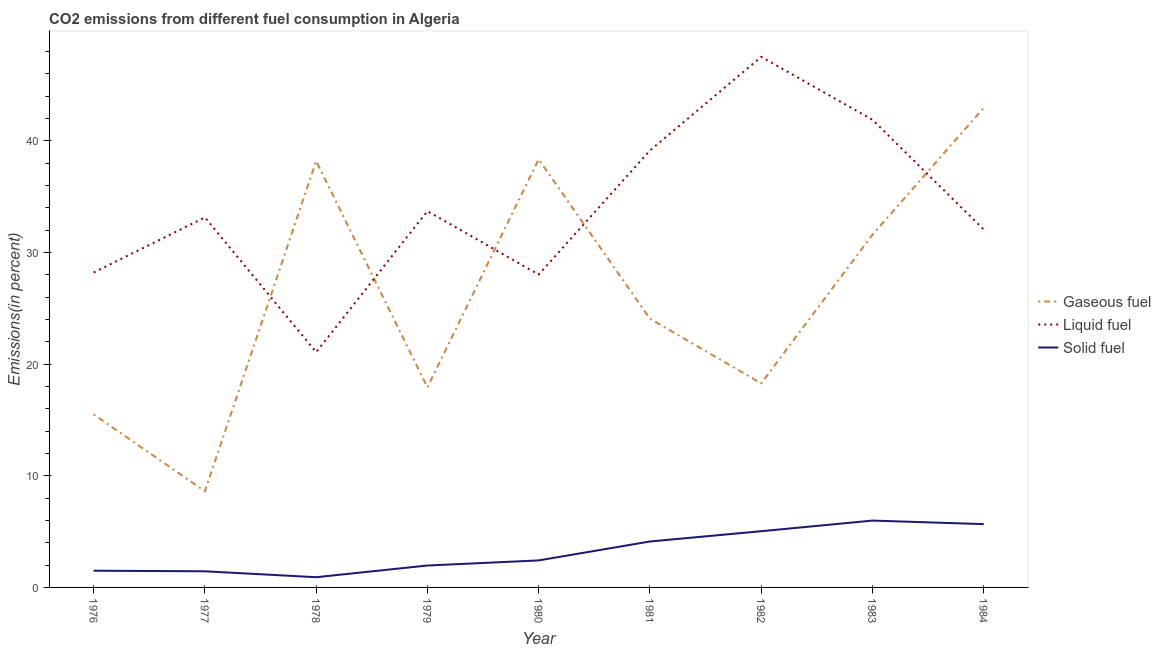How many different coloured lines are there?
Ensure brevity in your answer.  3. What is the percentage of liquid fuel emission in 1978?
Provide a succinct answer. 21.07. Across all years, what is the maximum percentage of solid fuel emission?
Offer a terse response. 5.99. Across all years, what is the minimum percentage of solid fuel emission?
Provide a succinct answer. 0.91. In which year was the percentage of gaseous fuel emission maximum?
Ensure brevity in your answer.  1984. What is the total percentage of solid fuel emission in the graph?
Offer a very short reply. 29.04. What is the difference between the percentage of liquid fuel emission in 1976 and that in 1981?
Offer a terse response. -10.93. What is the difference between the percentage of solid fuel emission in 1979 and the percentage of gaseous fuel emission in 1977?
Offer a very short reply. -6.65. What is the average percentage of solid fuel emission per year?
Your response must be concise. 3.23. In the year 1981, what is the difference between the percentage of gaseous fuel emission and percentage of liquid fuel emission?
Offer a terse response. -15.07. What is the ratio of the percentage of solid fuel emission in 1980 to that in 1983?
Provide a short and direct response. 0.4. What is the difference between the highest and the second highest percentage of liquid fuel emission?
Your response must be concise. 5.63. What is the difference between the highest and the lowest percentage of solid fuel emission?
Provide a succinct answer. 5.07. Is the sum of the percentage of liquid fuel emission in 1976 and 1977 greater than the maximum percentage of gaseous fuel emission across all years?
Give a very brief answer. Yes. Is it the case that in every year, the sum of the percentage of gaseous fuel emission and percentage of liquid fuel emission is greater than the percentage of solid fuel emission?
Your answer should be very brief. Yes. Is the percentage of solid fuel emission strictly greater than the percentage of gaseous fuel emission over the years?
Your response must be concise. No. How many lines are there?
Make the answer very short. 3. What is the difference between two consecutive major ticks on the Y-axis?
Provide a succinct answer. 10. Are the values on the major ticks of Y-axis written in scientific E-notation?
Ensure brevity in your answer.  No. How many legend labels are there?
Provide a succinct answer. 3. What is the title of the graph?
Your answer should be very brief. CO2 emissions from different fuel consumption in Algeria. What is the label or title of the Y-axis?
Your answer should be very brief. Emissions(in percent). What is the Emissions(in percent) in Gaseous fuel in 1976?
Keep it short and to the point. 15.49. What is the Emissions(in percent) in Liquid fuel in 1976?
Provide a short and direct response. 28.2. What is the Emissions(in percent) in Solid fuel in 1976?
Provide a succinct answer. 1.5. What is the Emissions(in percent) of Gaseous fuel in 1977?
Provide a succinct answer. 8.61. What is the Emissions(in percent) of Liquid fuel in 1977?
Offer a very short reply. 33.13. What is the Emissions(in percent) in Solid fuel in 1977?
Keep it short and to the point. 1.44. What is the Emissions(in percent) of Gaseous fuel in 1978?
Provide a short and direct response. 38.18. What is the Emissions(in percent) of Liquid fuel in 1978?
Give a very brief answer. 21.07. What is the Emissions(in percent) in Solid fuel in 1978?
Your answer should be compact. 0.91. What is the Emissions(in percent) of Gaseous fuel in 1979?
Ensure brevity in your answer.  17.92. What is the Emissions(in percent) in Liquid fuel in 1979?
Make the answer very short. 33.7. What is the Emissions(in percent) in Solid fuel in 1979?
Your response must be concise. 1.96. What is the Emissions(in percent) in Gaseous fuel in 1980?
Offer a terse response. 38.34. What is the Emissions(in percent) of Liquid fuel in 1980?
Keep it short and to the point. 28.02. What is the Emissions(in percent) in Solid fuel in 1980?
Give a very brief answer. 2.42. What is the Emissions(in percent) of Gaseous fuel in 1981?
Your response must be concise. 24.06. What is the Emissions(in percent) of Liquid fuel in 1981?
Make the answer very short. 39.13. What is the Emissions(in percent) in Solid fuel in 1981?
Your response must be concise. 4.11. What is the Emissions(in percent) in Gaseous fuel in 1982?
Keep it short and to the point. 18.27. What is the Emissions(in percent) of Liquid fuel in 1982?
Your answer should be compact. 47.51. What is the Emissions(in percent) of Solid fuel in 1982?
Provide a short and direct response. 5.03. What is the Emissions(in percent) of Gaseous fuel in 1983?
Offer a terse response. 31.59. What is the Emissions(in percent) in Liquid fuel in 1983?
Your answer should be very brief. 41.88. What is the Emissions(in percent) of Solid fuel in 1983?
Keep it short and to the point. 5.99. What is the Emissions(in percent) in Gaseous fuel in 1984?
Your answer should be very brief. 42.94. What is the Emissions(in percent) in Liquid fuel in 1984?
Give a very brief answer. 32.05. What is the Emissions(in percent) in Solid fuel in 1984?
Keep it short and to the point. 5.67. Across all years, what is the maximum Emissions(in percent) of Gaseous fuel?
Your answer should be very brief. 42.94. Across all years, what is the maximum Emissions(in percent) in Liquid fuel?
Give a very brief answer. 47.51. Across all years, what is the maximum Emissions(in percent) of Solid fuel?
Your answer should be very brief. 5.99. Across all years, what is the minimum Emissions(in percent) of Gaseous fuel?
Provide a succinct answer. 8.61. Across all years, what is the minimum Emissions(in percent) in Liquid fuel?
Provide a short and direct response. 21.07. Across all years, what is the minimum Emissions(in percent) in Solid fuel?
Your answer should be very brief. 0.91. What is the total Emissions(in percent) in Gaseous fuel in the graph?
Keep it short and to the point. 235.41. What is the total Emissions(in percent) in Liquid fuel in the graph?
Provide a short and direct response. 304.67. What is the total Emissions(in percent) in Solid fuel in the graph?
Your answer should be compact. 29.04. What is the difference between the Emissions(in percent) in Gaseous fuel in 1976 and that in 1977?
Offer a terse response. 6.88. What is the difference between the Emissions(in percent) in Liquid fuel in 1976 and that in 1977?
Your answer should be compact. -4.93. What is the difference between the Emissions(in percent) in Solid fuel in 1976 and that in 1977?
Your answer should be very brief. 0.05. What is the difference between the Emissions(in percent) of Gaseous fuel in 1976 and that in 1978?
Keep it short and to the point. -22.69. What is the difference between the Emissions(in percent) of Liquid fuel in 1976 and that in 1978?
Offer a terse response. 7.13. What is the difference between the Emissions(in percent) in Solid fuel in 1976 and that in 1978?
Offer a terse response. 0.58. What is the difference between the Emissions(in percent) of Gaseous fuel in 1976 and that in 1979?
Ensure brevity in your answer.  -2.42. What is the difference between the Emissions(in percent) of Liquid fuel in 1976 and that in 1979?
Ensure brevity in your answer.  -5.5. What is the difference between the Emissions(in percent) of Solid fuel in 1976 and that in 1979?
Make the answer very short. -0.46. What is the difference between the Emissions(in percent) in Gaseous fuel in 1976 and that in 1980?
Provide a succinct answer. -22.84. What is the difference between the Emissions(in percent) of Liquid fuel in 1976 and that in 1980?
Provide a succinct answer. 0.18. What is the difference between the Emissions(in percent) of Solid fuel in 1976 and that in 1980?
Your response must be concise. -0.92. What is the difference between the Emissions(in percent) in Gaseous fuel in 1976 and that in 1981?
Your answer should be compact. -8.57. What is the difference between the Emissions(in percent) of Liquid fuel in 1976 and that in 1981?
Give a very brief answer. -10.93. What is the difference between the Emissions(in percent) of Solid fuel in 1976 and that in 1981?
Keep it short and to the point. -2.62. What is the difference between the Emissions(in percent) in Gaseous fuel in 1976 and that in 1982?
Offer a very short reply. -2.78. What is the difference between the Emissions(in percent) in Liquid fuel in 1976 and that in 1982?
Your response must be concise. -19.31. What is the difference between the Emissions(in percent) in Solid fuel in 1976 and that in 1982?
Provide a succinct answer. -3.54. What is the difference between the Emissions(in percent) of Gaseous fuel in 1976 and that in 1983?
Keep it short and to the point. -16.09. What is the difference between the Emissions(in percent) in Liquid fuel in 1976 and that in 1983?
Make the answer very short. -13.68. What is the difference between the Emissions(in percent) in Solid fuel in 1976 and that in 1983?
Your response must be concise. -4.49. What is the difference between the Emissions(in percent) of Gaseous fuel in 1976 and that in 1984?
Offer a terse response. -27.45. What is the difference between the Emissions(in percent) in Liquid fuel in 1976 and that in 1984?
Your answer should be very brief. -3.85. What is the difference between the Emissions(in percent) of Solid fuel in 1976 and that in 1984?
Provide a succinct answer. -4.17. What is the difference between the Emissions(in percent) in Gaseous fuel in 1977 and that in 1978?
Make the answer very short. -29.57. What is the difference between the Emissions(in percent) of Liquid fuel in 1977 and that in 1978?
Your answer should be very brief. 12.06. What is the difference between the Emissions(in percent) of Solid fuel in 1977 and that in 1978?
Give a very brief answer. 0.53. What is the difference between the Emissions(in percent) in Gaseous fuel in 1977 and that in 1979?
Keep it short and to the point. -9.3. What is the difference between the Emissions(in percent) in Liquid fuel in 1977 and that in 1979?
Ensure brevity in your answer.  -0.56. What is the difference between the Emissions(in percent) of Solid fuel in 1977 and that in 1979?
Make the answer very short. -0.52. What is the difference between the Emissions(in percent) in Gaseous fuel in 1977 and that in 1980?
Give a very brief answer. -29.72. What is the difference between the Emissions(in percent) in Liquid fuel in 1977 and that in 1980?
Make the answer very short. 5.12. What is the difference between the Emissions(in percent) in Solid fuel in 1977 and that in 1980?
Keep it short and to the point. -0.98. What is the difference between the Emissions(in percent) of Gaseous fuel in 1977 and that in 1981?
Keep it short and to the point. -15.45. What is the difference between the Emissions(in percent) in Liquid fuel in 1977 and that in 1981?
Offer a very short reply. -5.99. What is the difference between the Emissions(in percent) of Solid fuel in 1977 and that in 1981?
Offer a very short reply. -2.67. What is the difference between the Emissions(in percent) of Gaseous fuel in 1977 and that in 1982?
Keep it short and to the point. -9.66. What is the difference between the Emissions(in percent) of Liquid fuel in 1977 and that in 1982?
Provide a succinct answer. -14.38. What is the difference between the Emissions(in percent) in Solid fuel in 1977 and that in 1982?
Offer a very short reply. -3.59. What is the difference between the Emissions(in percent) in Gaseous fuel in 1977 and that in 1983?
Give a very brief answer. -22.97. What is the difference between the Emissions(in percent) of Liquid fuel in 1977 and that in 1983?
Ensure brevity in your answer.  -8.75. What is the difference between the Emissions(in percent) in Solid fuel in 1977 and that in 1983?
Ensure brevity in your answer.  -4.54. What is the difference between the Emissions(in percent) of Gaseous fuel in 1977 and that in 1984?
Ensure brevity in your answer.  -34.33. What is the difference between the Emissions(in percent) in Liquid fuel in 1977 and that in 1984?
Your answer should be very brief. 1.08. What is the difference between the Emissions(in percent) in Solid fuel in 1977 and that in 1984?
Provide a succinct answer. -4.22. What is the difference between the Emissions(in percent) in Gaseous fuel in 1978 and that in 1979?
Offer a terse response. 20.27. What is the difference between the Emissions(in percent) of Liquid fuel in 1978 and that in 1979?
Offer a very short reply. -12.62. What is the difference between the Emissions(in percent) in Solid fuel in 1978 and that in 1979?
Offer a very short reply. -1.05. What is the difference between the Emissions(in percent) in Gaseous fuel in 1978 and that in 1980?
Your answer should be very brief. -0.15. What is the difference between the Emissions(in percent) in Liquid fuel in 1978 and that in 1980?
Provide a succinct answer. -6.94. What is the difference between the Emissions(in percent) of Solid fuel in 1978 and that in 1980?
Ensure brevity in your answer.  -1.51. What is the difference between the Emissions(in percent) of Gaseous fuel in 1978 and that in 1981?
Ensure brevity in your answer.  14.12. What is the difference between the Emissions(in percent) in Liquid fuel in 1978 and that in 1981?
Your answer should be compact. -18.06. What is the difference between the Emissions(in percent) of Solid fuel in 1978 and that in 1981?
Ensure brevity in your answer.  -3.2. What is the difference between the Emissions(in percent) in Gaseous fuel in 1978 and that in 1982?
Ensure brevity in your answer.  19.91. What is the difference between the Emissions(in percent) of Liquid fuel in 1978 and that in 1982?
Your response must be concise. -26.44. What is the difference between the Emissions(in percent) of Solid fuel in 1978 and that in 1982?
Your answer should be very brief. -4.12. What is the difference between the Emissions(in percent) in Gaseous fuel in 1978 and that in 1983?
Give a very brief answer. 6.6. What is the difference between the Emissions(in percent) of Liquid fuel in 1978 and that in 1983?
Give a very brief answer. -20.81. What is the difference between the Emissions(in percent) in Solid fuel in 1978 and that in 1983?
Your answer should be very brief. -5.07. What is the difference between the Emissions(in percent) of Gaseous fuel in 1978 and that in 1984?
Your response must be concise. -4.76. What is the difference between the Emissions(in percent) of Liquid fuel in 1978 and that in 1984?
Offer a very short reply. -10.98. What is the difference between the Emissions(in percent) in Solid fuel in 1978 and that in 1984?
Make the answer very short. -4.75. What is the difference between the Emissions(in percent) of Gaseous fuel in 1979 and that in 1980?
Offer a very short reply. -20.42. What is the difference between the Emissions(in percent) of Liquid fuel in 1979 and that in 1980?
Provide a succinct answer. 5.68. What is the difference between the Emissions(in percent) of Solid fuel in 1979 and that in 1980?
Your answer should be compact. -0.46. What is the difference between the Emissions(in percent) in Gaseous fuel in 1979 and that in 1981?
Provide a short and direct response. -6.14. What is the difference between the Emissions(in percent) of Liquid fuel in 1979 and that in 1981?
Keep it short and to the point. -5.43. What is the difference between the Emissions(in percent) of Solid fuel in 1979 and that in 1981?
Offer a very short reply. -2.15. What is the difference between the Emissions(in percent) of Gaseous fuel in 1979 and that in 1982?
Ensure brevity in your answer.  -0.36. What is the difference between the Emissions(in percent) of Liquid fuel in 1979 and that in 1982?
Your answer should be very brief. -13.82. What is the difference between the Emissions(in percent) of Solid fuel in 1979 and that in 1982?
Keep it short and to the point. -3.07. What is the difference between the Emissions(in percent) of Gaseous fuel in 1979 and that in 1983?
Ensure brevity in your answer.  -13.67. What is the difference between the Emissions(in percent) of Liquid fuel in 1979 and that in 1983?
Offer a terse response. -8.18. What is the difference between the Emissions(in percent) in Solid fuel in 1979 and that in 1983?
Your answer should be very brief. -4.02. What is the difference between the Emissions(in percent) in Gaseous fuel in 1979 and that in 1984?
Make the answer very short. -25.03. What is the difference between the Emissions(in percent) of Liquid fuel in 1979 and that in 1984?
Make the answer very short. 1.65. What is the difference between the Emissions(in percent) of Solid fuel in 1979 and that in 1984?
Your response must be concise. -3.71. What is the difference between the Emissions(in percent) in Gaseous fuel in 1980 and that in 1981?
Your answer should be very brief. 14.27. What is the difference between the Emissions(in percent) of Liquid fuel in 1980 and that in 1981?
Provide a succinct answer. -11.11. What is the difference between the Emissions(in percent) in Solid fuel in 1980 and that in 1981?
Make the answer very short. -1.69. What is the difference between the Emissions(in percent) of Gaseous fuel in 1980 and that in 1982?
Offer a very short reply. 20.06. What is the difference between the Emissions(in percent) of Liquid fuel in 1980 and that in 1982?
Provide a succinct answer. -19.5. What is the difference between the Emissions(in percent) in Solid fuel in 1980 and that in 1982?
Offer a terse response. -2.61. What is the difference between the Emissions(in percent) in Gaseous fuel in 1980 and that in 1983?
Offer a terse response. 6.75. What is the difference between the Emissions(in percent) in Liquid fuel in 1980 and that in 1983?
Provide a short and direct response. -13.86. What is the difference between the Emissions(in percent) in Solid fuel in 1980 and that in 1983?
Your answer should be very brief. -3.57. What is the difference between the Emissions(in percent) in Gaseous fuel in 1980 and that in 1984?
Your response must be concise. -4.61. What is the difference between the Emissions(in percent) of Liquid fuel in 1980 and that in 1984?
Offer a very short reply. -4.03. What is the difference between the Emissions(in percent) of Solid fuel in 1980 and that in 1984?
Your answer should be very brief. -3.25. What is the difference between the Emissions(in percent) in Gaseous fuel in 1981 and that in 1982?
Ensure brevity in your answer.  5.79. What is the difference between the Emissions(in percent) of Liquid fuel in 1981 and that in 1982?
Make the answer very short. -8.38. What is the difference between the Emissions(in percent) in Solid fuel in 1981 and that in 1982?
Offer a terse response. -0.92. What is the difference between the Emissions(in percent) of Gaseous fuel in 1981 and that in 1983?
Your answer should be very brief. -7.53. What is the difference between the Emissions(in percent) in Liquid fuel in 1981 and that in 1983?
Your answer should be compact. -2.75. What is the difference between the Emissions(in percent) in Solid fuel in 1981 and that in 1983?
Ensure brevity in your answer.  -1.87. What is the difference between the Emissions(in percent) in Gaseous fuel in 1981 and that in 1984?
Provide a succinct answer. -18.88. What is the difference between the Emissions(in percent) in Liquid fuel in 1981 and that in 1984?
Your answer should be very brief. 7.08. What is the difference between the Emissions(in percent) of Solid fuel in 1981 and that in 1984?
Offer a terse response. -1.55. What is the difference between the Emissions(in percent) of Gaseous fuel in 1982 and that in 1983?
Ensure brevity in your answer.  -13.31. What is the difference between the Emissions(in percent) of Liquid fuel in 1982 and that in 1983?
Ensure brevity in your answer.  5.63. What is the difference between the Emissions(in percent) in Solid fuel in 1982 and that in 1983?
Your response must be concise. -0.95. What is the difference between the Emissions(in percent) in Gaseous fuel in 1982 and that in 1984?
Give a very brief answer. -24.67. What is the difference between the Emissions(in percent) in Liquid fuel in 1982 and that in 1984?
Provide a succinct answer. 15.46. What is the difference between the Emissions(in percent) in Solid fuel in 1982 and that in 1984?
Give a very brief answer. -0.63. What is the difference between the Emissions(in percent) in Gaseous fuel in 1983 and that in 1984?
Ensure brevity in your answer.  -11.36. What is the difference between the Emissions(in percent) of Liquid fuel in 1983 and that in 1984?
Keep it short and to the point. 9.83. What is the difference between the Emissions(in percent) of Solid fuel in 1983 and that in 1984?
Offer a very short reply. 0.32. What is the difference between the Emissions(in percent) in Gaseous fuel in 1976 and the Emissions(in percent) in Liquid fuel in 1977?
Make the answer very short. -17.64. What is the difference between the Emissions(in percent) in Gaseous fuel in 1976 and the Emissions(in percent) in Solid fuel in 1977?
Your answer should be very brief. 14.05. What is the difference between the Emissions(in percent) of Liquid fuel in 1976 and the Emissions(in percent) of Solid fuel in 1977?
Give a very brief answer. 26.75. What is the difference between the Emissions(in percent) in Gaseous fuel in 1976 and the Emissions(in percent) in Liquid fuel in 1978?
Ensure brevity in your answer.  -5.58. What is the difference between the Emissions(in percent) of Gaseous fuel in 1976 and the Emissions(in percent) of Solid fuel in 1978?
Give a very brief answer. 14.58. What is the difference between the Emissions(in percent) in Liquid fuel in 1976 and the Emissions(in percent) in Solid fuel in 1978?
Your response must be concise. 27.28. What is the difference between the Emissions(in percent) in Gaseous fuel in 1976 and the Emissions(in percent) in Liquid fuel in 1979?
Make the answer very short. -18.2. What is the difference between the Emissions(in percent) of Gaseous fuel in 1976 and the Emissions(in percent) of Solid fuel in 1979?
Your answer should be very brief. 13.53. What is the difference between the Emissions(in percent) in Liquid fuel in 1976 and the Emissions(in percent) in Solid fuel in 1979?
Keep it short and to the point. 26.24. What is the difference between the Emissions(in percent) in Gaseous fuel in 1976 and the Emissions(in percent) in Liquid fuel in 1980?
Give a very brief answer. -12.52. What is the difference between the Emissions(in percent) of Gaseous fuel in 1976 and the Emissions(in percent) of Solid fuel in 1980?
Give a very brief answer. 13.07. What is the difference between the Emissions(in percent) in Liquid fuel in 1976 and the Emissions(in percent) in Solid fuel in 1980?
Keep it short and to the point. 25.78. What is the difference between the Emissions(in percent) of Gaseous fuel in 1976 and the Emissions(in percent) of Liquid fuel in 1981?
Give a very brief answer. -23.63. What is the difference between the Emissions(in percent) of Gaseous fuel in 1976 and the Emissions(in percent) of Solid fuel in 1981?
Make the answer very short. 11.38. What is the difference between the Emissions(in percent) of Liquid fuel in 1976 and the Emissions(in percent) of Solid fuel in 1981?
Offer a terse response. 24.08. What is the difference between the Emissions(in percent) in Gaseous fuel in 1976 and the Emissions(in percent) in Liquid fuel in 1982?
Your answer should be very brief. -32.02. What is the difference between the Emissions(in percent) of Gaseous fuel in 1976 and the Emissions(in percent) of Solid fuel in 1982?
Keep it short and to the point. 10.46. What is the difference between the Emissions(in percent) of Liquid fuel in 1976 and the Emissions(in percent) of Solid fuel in 1982?
Offer a terse response. 23.16. What is the difference between the Emissions(in percent) in Gaseous fuel in 1976 and the Emissions(in percent) in Liquid fuel in 1983?
Ensure brevity in your answer.  -26.39. What is the difference between the Emissions(in percent) of Gaseous fuel in 1976 and the Emissions(in percent) of Solid fuel in 1983?
Make the answer very short. 9.51. What is the difference between the Emissions(in percent) in Liquid fuel in 1976 and the Emissions(in percent) in Solid fuel in 1983?
Your response must be concise. 22.21. What is the difference between the Emissions(in percent) in Gaseous fuel in 1976 and the Emissions(in percent) in Liquid fuel in 1984?
Your answer should be compact. -16.55. What is the difference between the Emissions(in percent) in Gaseous fuel in 1976 and the Emissions(in percent) in Solid fuel in 1984?
Your answer should be compact. 9.83. What is the difference between the Emissions(in percent) of Liquid fuel in 1976 and the Emissions(in percent) of Solid fuel in 1984?
Provide a short and direct response. 22.53. What is the difference between the Emissions(in percent) in Gaseous fuel in 1977 and the Emissions(in percent) in Liquid fuel in 1978?
Make the answer very short. -12.46. What is the difference between the Emissions(in percent) of Gaseous fuel in 1977 and the Emissions(in percent) of Solid fuel in 1978?
Provide a succinct answer. 7.7. What is the difference between the Emissions(in percent) in Liquid fuel in 1977 and the Emissions(in percent) in Solid fuel in 1978?
Offer a terse response. 32.22. What is the difference between the Emissions(in percent) in Gaseous fuel in 1977 and the Emissions(in percent) in Liquid fuel in 1979?
Offer a very short reply. -25.08. What is the difference between the Emissions(in percent) of Gaseous fuel in 1977 and the Emissions(in percent) of Solid fuel in 1979?
Ensure brevity in your answer.  6.65. What is the difference between the Emissions(in percent) in Liquid fuel in 1977 and the Emissions(in percent) in Solid fuel in 1979?
Your response must be concise. 31.17. What is the difference between the Emissions(in percent) of Gaseous fuel in 1977 and the Emissions(in percent) of Liquid fuel in 1980?
Your response must be concise. -19.4. What is the difference between the Emissions(in percent) of Gaseous fuel in 1977 and the Emissions(in percent) of Solid fuel in 1980?
Offer a very short reply. 6.19. What is the difference between the Emissions(in percent) in Liquid fuel in 1977 and the Emissions(in percent) in Solid fuel in 1980?
Provide a short and direct response. 30.71. What is the difference between the Emissions(in percent) in Gaseous fuel in 1977 and the Emissions(in percent) in Liquid fuel in 1981?
Make the answer very short. -30.51. What is the difference between the Emissions(in percent) in Gaseous fuel in 1977 and the Emissions(in percent) in Solid fuel in 1981?
Keep it short and to the point. 4.5. What is the difference between the Emissions(in percent) of Liquid fuel in 1977 and the Emissions(in percent) of Solid fuel in 1981?
Offer a very short reply. 29.02. What is the difference between the Emissions(in percent) in Gaseous fuel in 1977 and the Emissions(in percent) in Liquid fuel in 1982?
Ensure brevity in your answer.  -38.9. What is the difference between the Emissions(in percent) of Gaseous fuel in 1977 and the Emissions(in percent) of Solid fuel in 1982?
Offer a very short reply. 3.58. What is the difference between the Emissions(in percent) in Liquid fuel in 1977 and the Emissions(in percent) in Solid fuel in 1982?
Keep it short and to the point. 28.1. What is the difference between the Emissions(in percent) in Gaseous fuel in 1977 and the Emissions(in percent) in Liquid fuel in 1983?
Offer a terse response. -33.27. What is the difference between the Emissions(in percent) in Gaseous fuel in 1977 and the Emissions(in percent) in Solid fuel in 1983?
Ensure brevity in your answer.  2.63. What is the difference between the Emissions(in percent) in Liquid fuel in 1977 and the Emissions(in percent) in Solid fuel in 1983?
Your answer should be very brief. 27.15. What is the difference between the Emissions(in percent) of Gaseous fuel in 1977 and the Emissions(in percent) of Liquid fuel in 1984?
Your answer should be compact. -23.43. What is the difference between the Emissions(in percent) of Gaseous fuel in 1977 and the Emissions(in percent) of Solid fuel in 1984?
Offer a very short reply. 2.95. What is the difference between the Emissions(in percent) in Liquid fuel in 1977 and the Emissions(in percent) in Solid fuel in 1984?
Keep it short and to the point. 27.46. What is the difference between the Emissions(in percent) of Gaseous fuel in 1978 and the Emissions(in percent) of Liquid fuel in 1979?
Make the answer very short. 4.49. What is the difference between the Emissions(in percent) in Gaseous fuel in 1978 and the Emissions(in percent) in Solid fuel in 1979?
Provide a succinct answer. 36.22. What is the difference between the Emissions(in percent) in Liquid fuel in 1978 and the Emissions(in percent) in Solid fuel in 1979?
Your answer should be compact. 19.11. What is the difference between the Emissions(in percent) of Gaseous fuel in 1978 and the Emissions(in percent) of Liquid fuel in 1980?
Your response must be concise. 10.17. What is the difference between the Emissions(in percent) in Gaseous fuel in 1978 and the Emissions(in percent) in Solid fuel in 1980?
Keep it short and to the point. 35.76. What is the difference between the Emissions(in percent) of Liquid fuel in 1978 and the Emissions(in percent) of Solid fuel in 1980?
Your answer should be very brief. 18.65. What is the difference between the Emissions(in percent) in Gaseous fuel in 1978 and the Emissions(in percent) in Liquid fuel in 1981?
Provide a short and direct response. -0.94. What is the difference between the Emissions(in percent) in Gaseous fuel in 1978 and the Emissions(in percent) in Solid fuel in 1981?
Give a very brief answer. 34.07. What is the difference between the Emissions(in percent) in Liquid fuel in 1978 and the Emissions(in percent) in Solid fuel in 1981?
Your response must be concise. 16.96. What is the difference between the Emissions(in percent) of Gaseous fuel in 1978 and the Emissions(in percent) of Liquid fuel in 1982?
Make the answer very short. -9.33. What is the difference between the Emissions(in percent) in Gaseous fuel in 1978 and the Emissions(in percent) in Solid fuel in 1982?
Give a very brief answer. 33.15. What is the difference between the Emissions(in percent) of Liquid fuel in 1978 and the Emissions(in percent) of Solid fuel in 1982?
Your answer should be compact. 16.04. What is the difference between the Emissions(in percent) of Gaseous fuel in 1978 and the Emissions(in percent) of Liquid fuel in 1983?
Provide a succinct answer. -3.7. What is the difference between the Emissions(in percent) in Gaseous fuel in 1978 and the Emissions(in percent) in Solid fuel in 1983?
Ensure brevity in your answer.  32.2. What is the difference between the Emissions(in percent) of Liquid fuel in 1978 and the Emissions(in percent) of Solid fuel in 1983?
Keep it short and to the point. 15.09. What is the difference between the Emissions(in percent) of Gaseous fuel in 1978 and the Emissions(in percent) of Liquid fuel in 1984?
Make the answer very short. 6.14. What is the difference between the Emissions(in percent) of Gaseous fuel in 1978 and the Emissions(in percent) of Solid fuel in 1984?
Provide a succinct answer. 32.52. What is the difference between the Emissions(in percent) in Liquid fuel in 1978 and the Emissions(in percent) in Solid fuel in 1984?
Provide a short and direct response. 15.4. What is the difference between the Emissions(in percent) in Gaseous fuel in 1979 and the Emissions(in percent) in Liquid fuel in 1980?
Offer a terse response. -10.1. What is the difference between the Emissions(in percent) of Gaseous fuel in 1979 and the Emissions(in percent) of Solid fuel in 1980?
Give a very brief answer. 15.5. What is the difference between the Emissions(in percent) in Liquid fuel in 1979 and the Emissions(in percent) in Solid fuel in 1980?
Your answer should be compact. 31.27. What is the difference between the Emissions(in percent) in Gaseous fuel in 1979 and the Emissions(in percent) in Liquid fuel in 1981?
Your answer should be compact. -21.21. What is the difference between the Emissions(in percent) of Gaseous fuel in 1979 and the Emissions(in percent) of Solid fuel in 1981?
Make the answer very short. 13.8. What is the difference between the Emissions(in percent) in Liquid fuel in 1979 and the Emissions(in percent) in Solid fuel in 1981?
Offer a very short reply. 29.58. What is the difference between the Emissions(in percent) of Gaseous fuel in 1979 and the Emissions(in percent) of Liquid fuel in 1982?
Your answer should be very brief. -29.59. What is the difference between the Emissions(in percent) of Gaseous fuel in 1979 and the Emissions(in percent) of Solid fuel in 1982?
Offer a terse response. 12.88. What is the difference between the Emissions(in percent) in Liquid fuel in 1979 and the Emissions(in percent) in Solid fuel in 1982?
Make the answer very short. 28.66. What is the difference between the Emissions(in percent) of Gaseous fuel in 1979 and the Emissions(in percent) of Liquid fuel in 1983?
Offer a very short reply. -23.96. What is the difference between the Emissions(in percent) in Gaseous fuel in 1979 and the Emissions(in percent) in Solid fuel in 1983?
Your response must be concise. 11.93. What is the difference between the Emissions(in percent) in Liquid fuel in 1979 and the Emissions(in percent) in Solid fuel in 1983?
Offer a very short reply. 27.71. What is the difference between the Emissions(in percent) of Gaseous fuel in 1979 and the Emissions(in percent) of Liquid fuel in 1984?
Your response must be concise. -14.13. What is the difference between the Emissions(in percent) in Gaseous fuel in 1979 and the Emissions(in percent) in Solid fuel in 1984?
Your answer should be compact. 12.25. What is the difference between the Emissions(in percent) of Liquid fuel in 1979 and the Emissions(in percent) of Solid fuel in 1984?
Make the answer very short. 28.03. What is the difference between the Emissions(in percent) in Gaseous fuel in 1980 and the Emissions(in percent) in Liquid fuel in 1981?
Provide a succinct answer. -0.79. What is the difference between the Emissions(in percent) in Gaseous fuel in 1980 and the Emissions(in percent) in Solid fuel in 1981?
Give a very brief answer. 34.22. What is the difference between the Emissions(in percent) in Liquid fuel in 1980 and the Emissions(in percent) in Solid fuel in 1981?
Your answer should be compact. 23.9. What is the difference between the Emissions(in percent) in Gaseous fuel in 1980 and the Emissions(in percent) in Liquid fuel in 1982?
Give a very brief answer. -9.18. What is the difference between the Emissions(in percent) in Gaseous fuel in 1980 and the Emissions(in percent) in Solid fuel in 1982?
Provide a short and direct response. 33.3. What is the difference between the Emissions(in percent) in Liquid fuel in 1980 and the Emissions(in percent) in Solid fuel in 1982?
Ensure brevity in your answer.  22.98. What is the difference between the Emissions(in percent) in Gaseous fuel in 1980 and the Emissions(in percent) in Liquid fuel in 1983?
Your answer should be compact. -3.54. What is the difference between the Emissions(in percent) in Gaseous fuel in 1980 and the Emissions(in percent) in Solid fuel in 1983?
Provide a short and direct response. 32.35. What is the difference between the Emissions(in percent) of Liquid fuel in 1980 and the Emissions(in percent) of Solid fuel in 1983?
Offer a terse response. 22.03. What is the difference between the Emissions(in percent) of Gaseous fuel in 1980 and the Emissions(in percent) of Liquid fuel in 1984?
Provide a short and direct response. 6.29. What is the difference between the Emissions(in percent) of Gaseous fuel in 1980 and the Emissions(in percent) of Solid fuel in 1984?
Your answer should be compact. 32.67. What is the difference between the Emissions(in percent) of Liquid fuel in 1980 and the Emissions(in percent) of Solid fuel in 1984?
Offer a very short reply. 22.35. What is the difference between the Emissions(in percent) of Gaseous fuel in 1981 and the Emissions(in percent) of Liquid fuel in 1982?
Your response must be concise. -23.45. What is the difference between the Emissions(in percent) in Gaseous fuel in 1981 and the Emissions(in percent) in Solid fuel in 1982?
Make the answer very short. 19.03. What is the difference between the Emissions(in percent) of Liquid fuel in 1981 and the Emissions(in percent) of Solid fuel in 1982?
Provide a short and direct response. 34.09. What is the difference between the Emissions(in percent) of Gaseous fuel in 1981 and the Emissions(in percent) of Liquid fuel in 1983?
Keep it short and to the point. -17.82. What is the difference between the Emissions(in percent) of Gaseous fuel in 1981 and the Emissions(in percent) of Solid fuel in 1983?
Your answer should be compact. 18.07. What is the difference between the Emissions(in percent) of Liquid fuel in 1981 and the Emissions(in percent) of Solid fuel in 1983?
Make the answer very short. 33.14. What is the difference between the Emissions(in percent) of Gaseous fuel in 1981 and the Emissions(in percent) of Liquid fuel in 1984?
Keep it short and to the point. -7.99. What is the difference between the Emissions(in percent) in Gaseous fuel in 1981 and the Emissions(in percent) in Solid fuel in 1984?
Offer a terse response. 18.39. What is the difference between the Emissions(in percent) in Liquid fuel in 1981 and the Emissions(in percent) in Solid fuel in 1984?
Make the answer very short. 33.46. What is the difference between the Emissions(in percent) in Gaseous fuel in 1982 and the Emissions(in percent) in Liquid fuel in 1983?
Your answer should be very brief. -23.6. What is the difference between the Emissions(in percent) of Gaseous fuel in 1982 and the Emissions(in percent) of Solid fuel in 1983?
Keep it short and to the point. 12.29. What is the difference between the Emissions(in percent) in Liquid fuel in 1982 and the Emissions(in percent) in Solid fuel in 1983?
Give a very brief answer. 41.53. What is the difference between the Emissions(in percent) of Gaseous fuel in 1982 and the Emissions(in percent) of Liquid fuel in 1984?
Provide a succinct answer. -13.77. What is the difference between the Emissions(in percent) of Gaseous fuel in 1982 and the Emissions(in percent) of Solid fuel in 1984?
Make the answer very short. 12.61. What is the difference between the Emissions(in percent) of Liquid fuel in 1982 and the Emissions(in percent) of Solid fuel in 1984?
Give a very brief answer. 41.84. What is the difference between the Emissions(in percent) of Gaseous fuel in 1983 and the Emissions(in percent) of Liquid fuel in 1984?
Your answer should be compact. -0.46. What is the difference between the Emissions(in percent) of Gaseous fuel in 1983 and the Emissions(in percent) of Solid fuel in 1984?
Your answer should be compact. 25.92. What is the difference between the Emissions(in percent) in Liquid fuel in 1983 and the Emissions(in percent) in Solid fuel in 1984?
Ensure brevity in your answer.  36.21. What is the average Emissions(in percent) of Gaseous fuel per year?
Provide a succinct answer. 26.16. What is the average Emissions(in percent) of Liquid fuel per year?
Provide a succinct answer. 33.85. What is the average Emissions(in percent) of Solid fuel per year?
Offer a terse response. 3.23. In the year 1976, what is the difference between the Emissions(in percent) in Gaseous fuel and Emissions(in percent) in Liquid fuel?
Ensure brevity in your answer.  -12.7. In the year 1976, what is the difference between the Emissions(in percent) of Gaseous fuel and Emissions(in percent) of Solid fuel?
Ensure brevity in your answer.  14. In the year 1976, what is the difference between the Emissions(in percent) of Liquid fuel and Emissions(in percent) of Solid fuel?
Provide a short and direct response. 26.7. In the year 1977, what is the difference between the Emissions(in percent) in Gaseous fuel and Emissions(in percent) in Liquid fuel?
Offer a terse response. -24.52. In the year 1977, what is the difference between the Emissions(in percent) of Gaseous fuel and Emissions(in percent) of Solid fuel?
Provide a succinct answer. 7.17. In the year 1977, what is the difference between the Emissions(in percent) of Liquid fuel and Emissions(in percent) of Solid fuel?
Ensure brevity in your answer.  31.69. In the year 1978, what is the difference between the Emissions(in percent) in Gaseous fuel and Emissions(in percent) in Liquid fuel?
Provide a succinct answer. 17.11. In the year 1978, what is the difference between the Emissions(in percent) in Gaseous fuel and Emissions(in percent) in Solid fuel?
Provide a short and direct response. 37.27. In the year 1978, what is the difference between the Emissions(in percent) of Liquid fuel and Emissions(in percent) of Solid fuel?
Provide a short and direct response. 20.16. In the year 1979, what is the difference between the Emissions(in percent) of Gaseous fuel and Emissions(in percent) of Liquid fuel?
Keep it short and to the point. -15.78. In the year 1979, what is the difference between the Emissions(in percent) in Gaseous fuel and Emissions(in percent) in Solid fuel?
Make the answer very short. 15.96. In the year 1979, what is the difference between the Emissions(in percent) of Liquid fuel and Emissions(in percent) of Solid fuel?
Make the answer very short. 31.73. In the year 1980, what is the difference between the Emissions(in percent) in Gaseous fuel and Emissions(in percent) in Liquid fuel?
Your answer should be very brief. 10.32. In the year 1980, what is the difference between the Emissions(in percent) in Gaseous fuel and Emissions(in percent) in Solid fuel?
Offer a very short reply. 35.92. In the year 1980, what is the difference between the Emissions(in percent) in Liquid fuel and Emissions(in percent) in Solid fuel?
Offer a very short reply. 25.6. In the year 1981, what is the difference between the Emissions(in percent) of Gaseous fuel and Emissions(in percent) of Liquid fuel?
Offer a very short reply. -15.07. In the year 1981, what is the difference between the Emissions(in percent) in Gaseous fuel and Emissions(in percent) in Solid fuel?
Offer a terse response. 19.95. In the year 1981, what is the difference between the Emissions(in percent) of Liquid fuel and Emissions(in percent) of Solid fuel?
Ensure brevity in your answer.  35.01. In the year 1982, what is the difference between the Emissions(in percent) of Gaseous fuel and Emissions(in percent) of Liquid fuel?
Give a very brief answer. -29.24. In the year 1982, what is the difference between the Emissions(in percent) of Gaseous fuel and Emissions(in percent) of Solid fuel?
Your answer should be very brief. 13.24. In the year 1982, what is the difference between the Emissions(in percent) in Liquid fuel and Emissions(in percent) in Solid fuel?
Keep it short and to the point. 42.48. In the year 1983, what is the difference between the Emissions(in percent) in Gaseous fuel and Emissions(in percent) in Liquid fuel?
Your answer should be very brief. -10.29. In the year 1983, what is the difference between the Emissions(in percent) in Gaseous fuel and Emissions(in percent) in Solid fuel?
Make the answer very short. 25.6. In the year 1983, what is the difference between the Emissions(in percent) in Liquid fuel and Emissions(in percent) in Solid fuel?
Provide a short and direct response. 35.89. In the year 1984, what is the difference between the Emissions(in percent) of Gaseous fuel and Emissions(in percent) of Liquid fuel?
Provide a short and direct response. 10.9. In the year 1984, what is the difference between the Emissions(in percent) of Gaseous fuel and Emissions(in percent) of Solid fuel?
Keep it short and to the point. 37.28. In the year 1984, what is the difference between the Emissions(in percent) in Liquid fuel and Emissions(in percent) in Solid fuel?
Offer a very short reply. 26.38. What is the ratio of the Emissions(in percent) of Gaseous fuel in 1976 to that in 1977?
Give a very brief answer. 1.8. What is the ratio of the Emissions(in percent) in Liquid fuel in 1976 to that in 1977?
Keep it short and to the point. 0.85. What is the ratio of the Emissions(in percent) in Solid fuel in 1976 to that in 1977?
Provide a short and direct response. 1.04. What is the ratio of the Emissions(in percent) of Gaseous fuel in 1976 to that in 1978?
Your response must be concise. 0.41. What is the ratio of the Emissions(in percent) of Liquid fuel in 1976 to that in 1978?
Give a very brief answer. 1.34. What is the ratio of the Emissions(in percent) of Solid fuel in 1976 to that in 1978?
Offer a very short reply. 1.64. What is the ratio of the Emissions(in percent) of Gaseous fuel in 1976 to that in 1979?
Offer a terse response. 0.86. What is the ratio of the Emissions(in percent) in Liquid fuel in 1976 to that in 1979?
Give a very brief answer. 0.84. What is the ratio of the Emissions(in percent) of Solid fuel in 1976 to that in 1979?
Your answer should be compact. 0.76. What is the ratio of the Emissions(in percent) of Gaseous fuel in 1976 to that in 1980?
Offer a terse response. 0.4. What is the ratio of the Emissions(in percent) of Solid fuel in 1976 to that in 1980?
Provide a short and direct response. 0.62. What is the ratio of the Emissions(in percent) in Gaseous fuel in 1976 to that in 1981?
Your response must be concise. 0.64. What is the ratio of the Emissions(in percent) of Liquid fuel in 1976 to that in 1981?
Give a very brief answer. 0.72. What is the ratio of the Emissions(in percent) in Solid fuel in 1976 to that in 1981?
Provide a short and direct response. 0.36. What is the ratio of the Emissions(in percent) of Gaseous fuel in 1976 to that in 1982?
Provide a succinct answer. 0.85. What is the ratio of the Emissions(in percent) of Liquid fuel in 1976 to that in 1982?
Your answer should be very brief. 0.59. What is the ratio of the Emissions(in percent) of Solid fuel in 1976 to that in 1982?
Provide a short and direct response. 0.3. What is the ratio of the Emissions(in percent) of Gaseous fuel in 1976 to that in 1983?
Your response must be concise. 0.49. What is the ratio of the Emissions(in percent) in Liquid fuel in 1976 to that in 1983?
Offer a very short reply. 0.67. What is the ratio of the Emissions(in percent) in Solid fuel in 1976 to that in 1983?
Make the answer very short. 0.25. What is the ratio of the Emissions(in percent) of Gaseous fuel in 1976 to that in 1984?
Your response must be concise. 0.36. What is the ratio of the Emissions(in percent) of Liquid fuel in 1976 to that in 1984?
Ensure brevity in your answer.  0.88. What is the ratio of the Emissions(in percent) of Solid fuel in 1976 to that in 1984?
Provide a short and direct response. 0.26. What is the ratio of the Emissions(in percent) in Gaseous fuel in 1977 to that in 1978?
Offer a very short reply. 0.23. What is the ratio of the Emissions(in percent) in Liquid fuel in 1977 to that in 1978?
Your answer should be very brief. 1.57. What is the ratio of the Emissions(in percent) in Solid fuel in 1977 to that in 1978?
Offer a terse response. 1.58. What is the ratio of the Emissions(in percent) in Gaseous fuel in 1977 to that in 1979?
Provide a short and direct response. 0.48. What is the ratio of the Emissions(in percent) in Liquid fuel in 1977 to that in 1979?
Ensure brevity in your answer.  0.98. What is the ratio of the Emissions(in percent) of Solid fuel in 1977 to that in 1979?
Offer a terse response. 0.74. What is the ratio of the Emissions(in percent) in Gaseous fuel in 1977 to that in 1980?
Give a very brief answer. 0.22. What is the ratio of the Emissions(in percent) of Liquid fuel in 1977 to that in 1980?
Ensure brevity in your answer.  1.18. What is the ratio of the Emissions(in percent) in Solid fuel in 1977 to that in 1980?
Make the answer very short. 0.6. What is the ratio of the Emissions(in percent) in Gaseous fuel in 1977 to that in 1981?
Your answer should be very brief. 0.36. What is the ratio of the Emissions(in percent) in Liquid fuel in 1977 to that in 1981?
Your answer should be very brief. 0.85. What is the ratio of the Emissions(in percent) in Solid fuel in 1977 to that in 1981?
Provide a succinct answer. 0.35. What is the ratio of the Emissions(in percent) in Gaseous fuel in 1977 to that in 1982?
Your answer should be compact. 0.47. What is the ratio of the Emissions(in percent) of Liquid fuel in 1977 to that in 1982?
Provide a short and direct response. 0.7. What is the ratio of the Emissions(in percent) of Solid fuel in 1977 to that in 1982?
Offer a terse response. 0.29. What is the ratio of the Emissions(in percent) of Gaseous fuel in 1977 to that in 1983?
Your response must be concise. 0.27. What is the ratio of the Emissions(in percent) in Liquid fuel in 1977 to that in 1983?
Offer a terse response. 0.79. What is the ratio of the Emissions(in percent) of Solid fuel in 1977 to that in 1983?
Your answer should be very brief. 0.24. What is the ratio of the Emissions(in percent) in Gaseous fuel in 1977 to that in 1984?
Offer a very short reply. 0.2. What is the ratio of the Emissions(in percent) in Liquid fuel in 1977 to that in 1984?
Your answer should be compact. 1.03. What is the ratio of the Emissions(in percent) of Solid fuel in 1977 to that in 1984?
Your answer should be very brief. 0.25. What is the ratio of the Emissions(in percent) in Gaseous fuel in 1978 to that in 1979?
Provide a succinct answer. 2.13. What is the ratio of the Emissions(in percent) in Liquid fuel in 1978 to that in 1979?
Provide a succinct answer. 0.63. What is the ratio of the Emissions(in percent) of Solid fuel in 1978 to that in 1979?
Your answer should be compact. 0.47. What is the ratio of the Emissions(in percent) of Liquid fuel in 1978 to that in 1980?
Offer a very short reply. 0.75. What is the ratio of the Emissions(in percent) in Solid fuel in 1978 to that in 1980?
Offer a terse response. 0.38. What is the ratio of the Emissions(in percent) in Gaseous fuel in 1978 to that in 1981?
Your answer should be compact. 1.59. What is the ratio of the Emissions(in percent) in Liquid fuel in 1978 to that in 1981?
Offer a very short reply. 0.54. What is the ratio of the Emissions(in percent) in Solid fuel in 1978 to that in 1981?
Give a very brief answer. 0.22. What is the ratio of the Emissions(in percent) in Gaseous fuel in 1978 to that in 1982?
Make the answer very short. 2.09. What is the ratio of the Emissions(in percent) of Liquid fuel in 1978 to that in 1982?
Offer a terse response. 0.44. What is the ratio of the Emissions(in percent) in Solid fuel in 1978 to that in 1982?
Offer a terse response. 0.18. What is the ratio of the Emissions(in percent) in Gaseous fuel in 1978 to that in 1983?
Your answer should be very brief. 1.21. What is the ratio of the Emissions(in percent) in Liquid fuel in 1978 to that in 1983?
Give a very brief answer. 0.5. What is the ratio of the Emissions(in percent) in Solid fuel in 1978 to that in 1983?
Make the answer very short. 0.15. What is the ratio of the Emissions(in percent) of Gaseous fuel in 1978 to that in 1984?
Make the answer very short. 0.89. What is the ratio of the Emissions(in percent) of Liquid fuel in 1978 to that in 1984?
Keep it short and to the point. 0.66. What is the ratio of the Emissions(in percent) in Solid fuel in 1978 to that in 1984?
Offer a terse response. 0.16. What is the ratio of the Emissions(in percent) of Gaseous fuel in 1979 to that in 1980?
Provide a succinct answer. 0.47. What is the ratio of the Emissions(in percent) in Liquid fuel in 1979 to that in 1980?
Your response must be concise. 1.2. What is the ratio of the Emissions(in percent) of Solid fuel in 1979 to that in 1980?
Provide a short and direct response. 0.81. What is the ratio of the Emissions(in percent) in Gaseous fuel in 1979 to that in 1981?
Give a very brief answer. 0.74. What is the ratio of the Emissions(in percent) in Liquid fuel in 1979 to that in 1981?
Your answer should be very brief. 0.86. What is the ratio of the Emissions(in percent) of Solid fuel in 1979 to that in 1981?
Ensure brevity in your answer.  0.48. What is the ratio of the Emissions(in percent) of Gaseous fuel in 1979 to that in 1982?
Give a very brief answer. 0.98. What is the ratio of the Emissions(in percent) of Liquid fuel in 1979 to that in 1982?
Your answer should be very brief. 0.71. What is the ratio of the Emissions(in percent) of Solid fuel in 1979 to that in 1982?
Provide a short and direct response. 0.39. What is the ratio of the Emissions(in percent) in Gaseous fuel in 1979 to that in 1983?
Offer a terse response. 0.57. What is the ratio of the Emissions(in percent) in Liquid fuel in 1979 to that in 1983?
Ensure brevity in your answer.  0.8. What is the ratio of the Emissions(in percent) in Solid fuel in 1979 to that in 1983?
Keep it short and to the point. 0.33. What is the ratio of the Emissions(in percent) in Gaseous fuel in 1979 to that in 1984?
Offer a very short reply. 0.42. What is the ratio of the Emissions(in percent) in Liquid fuel in 1979 to that in 1984?
Keep it short and to the point. 1.05. What is the ratio of the Emissions(in percent) of Solid fuel in 1979 to that in 1984?
Give a very brief answer. 0.35. What is the ratio of the Emissions(in percent) of Gaseous fuel in 1980 to that in 1981?
Make the answer very short. 1.59. What is the ratio of the Emissions(in percent) of Liquid fuel in 1980 to that in 1981?
Provide a succinct answer. 0.72. What is the ratio of the Emissions(in percent) of Solid fuel in 1980 to that in 1981?
Your answer should be very brief. 0.59. What is the ratio of the Emissions(in percent) in Gaseous fuel in 1980 to that in 1982?
Keep it short and to the point. 2.1. What is the ratio of the Emissions(in percent) in Liquid fuel in 1980 to that in 1982?
Keep it short and to the point. 0.59. What is the ratio of the Emissions(in percent) of Solid fuel in 1980 to that in 1982?
Offer a terse response. 0.48. What is the ratio of the Emissions(in percent) in Gaseous fuel in 1980 to that in 1983?
Offer a terse response. 1.21. What is the ratio of the Emissions(in percent) of Liquid fuel in 1980 to that in 1983?
Keep it short and to the point. 0.67. What is the ratio of the Emissions(in percent) of Solid fuel in 1980 to that in 1983?
Keep it short and to the point. 0.4. What is the ratio of the Emissions(in percent) in Gaseous fuel in 1980 to that in 1984?
Your answer should be very brief. 0.89. What is the ratio of the Emissions(in percent) of Liquid fuel in 1980 to that in 1984?
Your answer should be very brief. 0.87. What is the ratio of the Emissions(in percent) in Solid fuel in 1980 to that in 1984?
Your answer should be compact. 0.43. What is the ratio of the Emissions(in percent) of Gaseous fuel in 1981 to that in 1982?
Provide a succinct answer. 1.32. What is the ratio of the Emissions(in percent) of Liquid fuel in 1981 to that in 1982?
Keep it short and to the point. 0.82. What is the ratio of the Emissions(in percent) in Solid fuel in 1981 to that in 1982?
Offer a very short reply. 0.82. What is the ratio of the Emissions(in percent) in Gaseous fuel in 1981 to that in 1983?
Your response must be concise. 0.76. What is the ratio of the Emissions(in percent) of Liquid fuel in 1981 to that in 1983?
Keep it short and to the point. 0.93. What is the ratio of the Emissions(in percent) of Solid fuel in 1981 to that in 1983?
Provide a short and direct response. 0.69. What is the ratio of the Emissions(in percent) in Gaseous fuel in 1981 to that in 1984?
Your answer should be compact. 0.56. What is the ratio of the Emissions(in percent) of Liquid fuel in 1981 to that in 1984?
Your answer should be compact. 1.22. What is the ratio of the Emissions(in percent) in Solid fuel in 1981 to that in 1984?
Provide a succinct answer. 0.73. What is the ratio of the Emissions(in percent) of Gaseous fuel in 1982 to that in 1983?
Give a very brief answer. 0.58. What is the ratio of the Emissions(in percent) in Liquid fuel in 1982 to that in 1983?
Provide a short and direct response. 1.13. What is the ratio of the Emissions(in percent) of Solid fuel in 1982 to that in 1983?
Offer a terse response. 0.84. What is the ratio of the Emissions(in percent) of Gaseous fuel in 1982 to that in 1984?
Offer a terse response. 0.43. What is the ratio of the Emissions(in percent) of Liquid fuel in 1982 to that in 1984?
Keep it short and to the point. 1.48. What is the ratio of the Emissions(in percent) of Solid fuel in 1982 to that in 1984?
Your answer should be compact. 0.89. What is the ratio of the Emissions(in percent) of Gaseous fuel in 1983 to that in 1984?
Offer a very short reply. 0.74. What is the ratio of the Emissions(in percent) in Liquid fuel in 1983 to that in 1984?
Ensure brevity in your answer.  1.31. What is the ratio of the Emissions(in percent) of Solid fuel in 1983 to that in 1984?
Your answer should be compact. 1.06. What is the difference between the highest and the second highest Emissions(in percent) in Gaseous fuel?
Ensure brevity in your answer.  4.61. What is the difference between the highest and the second highest Emissions(in percent) of Liquid fuel?
Your response must be concise. 5.63. What is the difference between the highest and the second highest Emissions(in percent) in Solid fuel?
Ensure brevity in your answer.  0.32. What is the difference between the highest and the lowest Emissions(in percent) of Gaseous fuel?
Keep it short and to the point. 34.33. What is the difference between the highest and the lowest Emissions(in percent) of Liquid fuel?
Keep it short and to the point. 26.44. What is the difference between the highest and the lowest Emissions(in percent) in Solid fuel?
Your response must be concise. 5.07. 